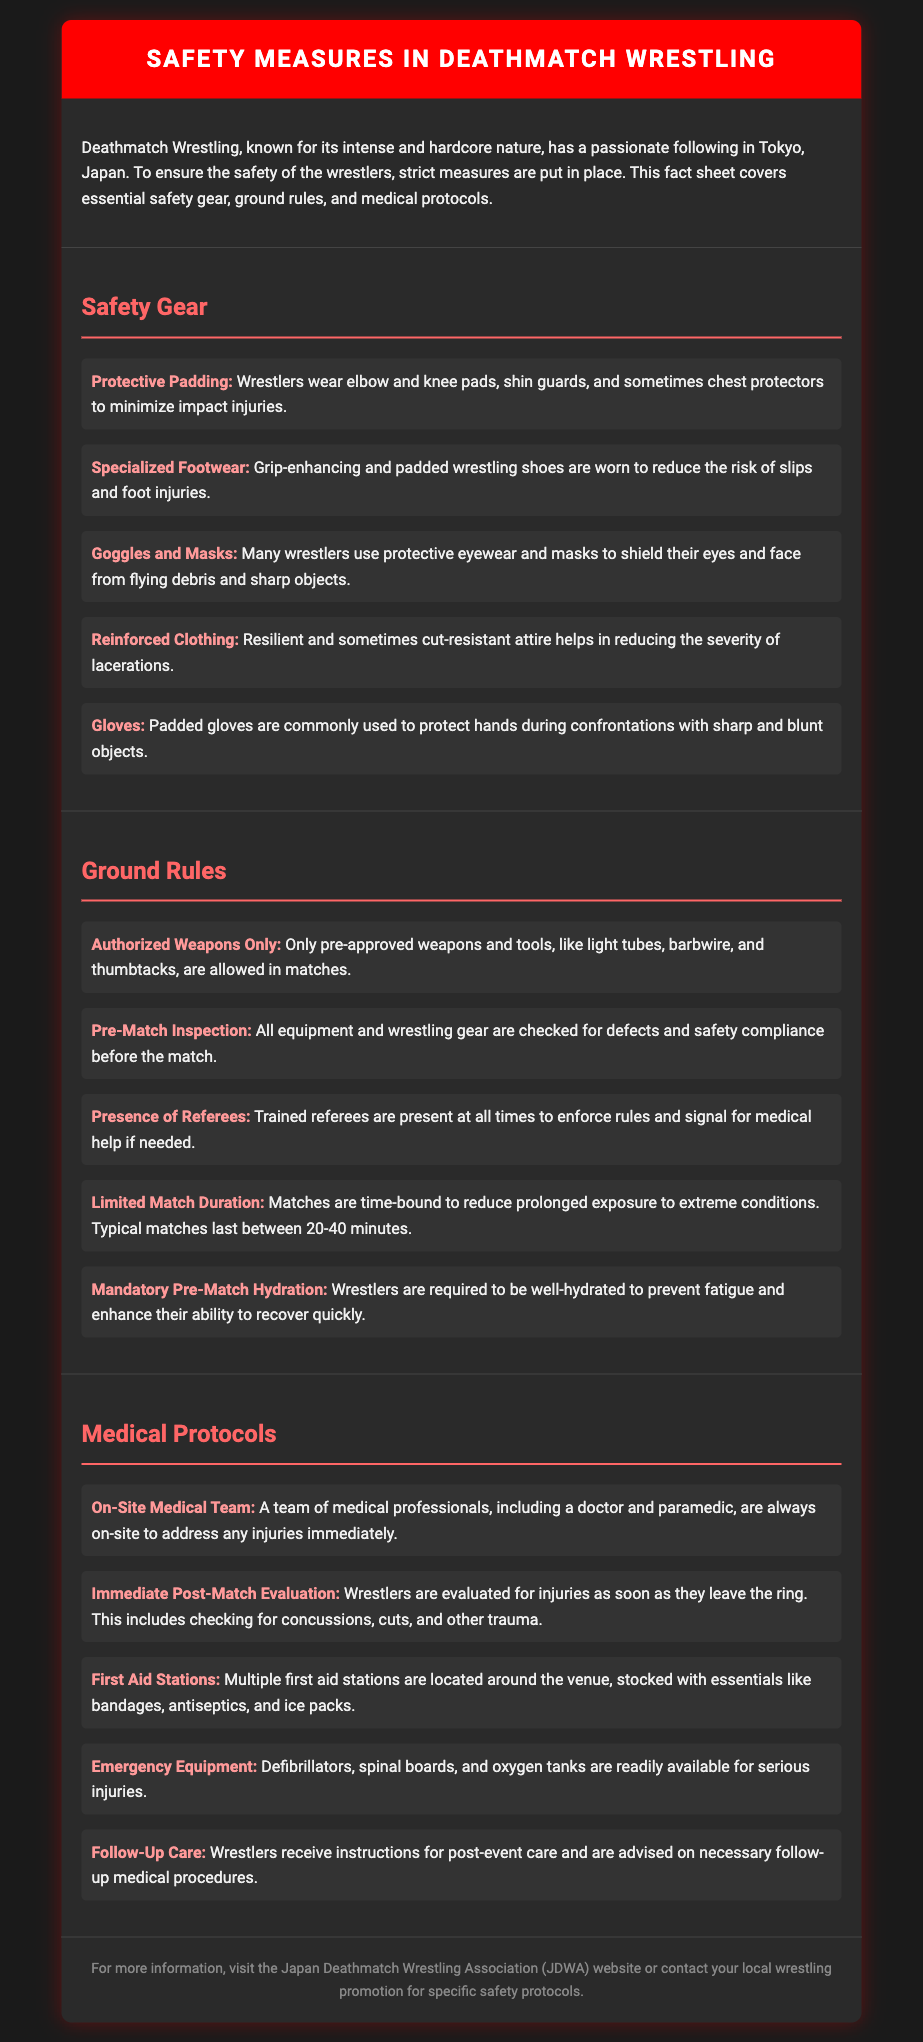what is the main focus of the fact sheet? The fact sheet covers essential safety measures in Deathmatch Wrestling, including gear, ground rules, and medical protocols.
Answer: safety measures in Deathmatch Wrestling what type of padding do wrestlers wear? Wrestlers wear elbow and knee pads, shin guards, and sometimes chest protectors to minimize impact injuries.
Answer: protective padding how many minutes do typical matches last? Matches are typically time-bound to reduce prolonged exposure to extreme conditions, lasting between 20-40 minutes.
Answer: 20-40 minutes who is present at all times during matches? Trained referees are present at all times to enforce rules and signal for medical help if needed.
Answer: trained referees what equipment is required for on-site medical care? A team of medical professionals, including a doctor and paramedic, are always on-site to address any injuries immediately.
Answer: medical team what must wrestlers do before a match? Wrestlers are required to be well-hydrated to prevent fatigue and enhance their ability to recover quickly.
Answer: mandatory pre-match hydration what are the first aid stations stocked with? First aid stations are stocked with essentials like bandages, antiseptics, and ice packs.
Answer: bandages, antiseptics, and ice packs what type of footwear do wrestlers use? Grip-enhancing and padded wrestling shoes are worn to reduce the risk of slips and foot injuries.
Answer: specialized footwear 